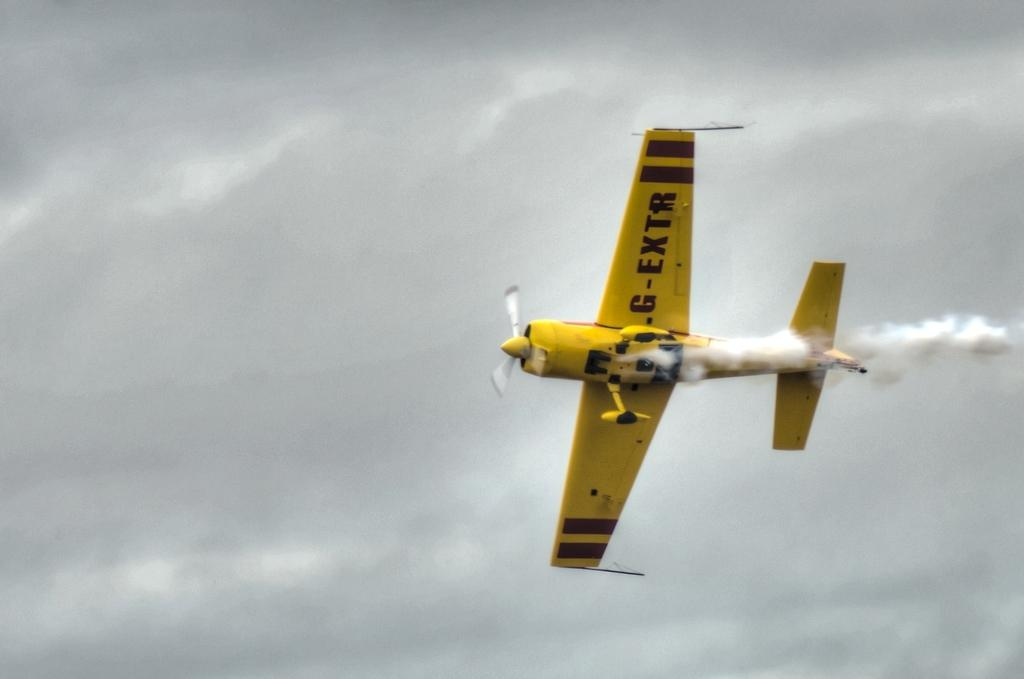What is the main subject of the image? The main subject of the image is an aircraft. What is the aircraft doing in the image? The aircraft is flying in the air. What can be seen coming from the aircraft in the image? There is smoke visible in the image. What is visible in the background of the image? The sky is visible in the background of the image. What type of wool can be seen on the aircraft's wheels in the image? There are no wheels or wool present in the image; it features an aircraft flying in the air with smoke visible. 